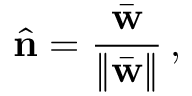Convert formula to latex. <formula><loc_0><loc_0><loc_500><loc_500>\hat { n } = \frac { \bar { w } } { \| \bar { w } \| } \, ,</formula> 